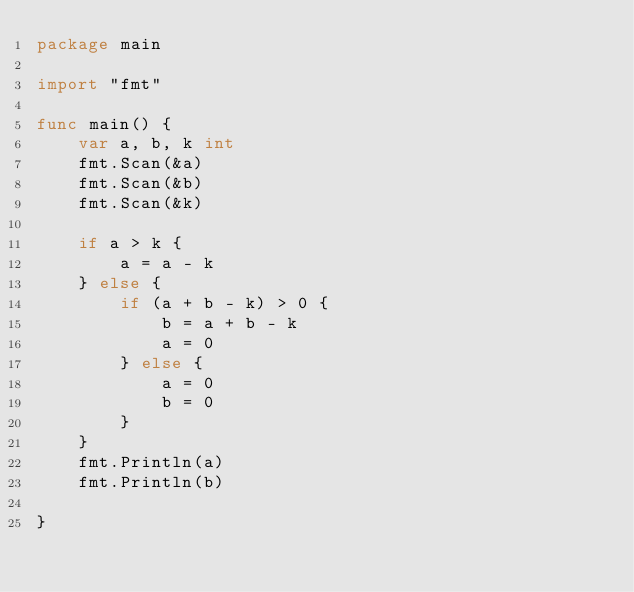<code> <loc_0><loc_0><loc_500><loc_500><_Go_>package main

import "fmt"

func main() {
	var a, b, k int
	fmt.Scan(&a)
	fmt.Scan(&b)
	fmt.Scan(&k)

	if a > k {
		a = a - k
	} else {
		if (a + b - k) > 0 {
			b = a + b - k
			a = 0
		} else {
			a = 0
			b = 0
		}
	}
	fmt.Println(a)
	fmt.Println(b)

}
</code> 